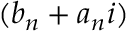<formula> <loc_0><loc_0><loc_500><loc_500>( b _ { n } + a _ { n } i )</formula> 